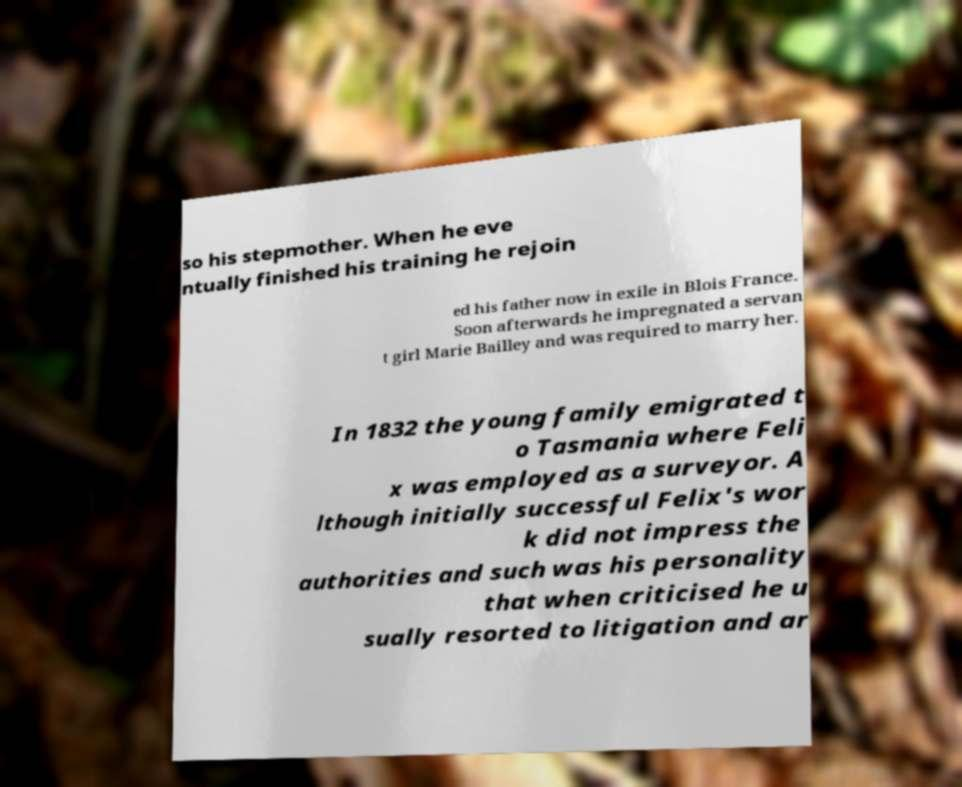Please read and relay the text visible in this image. What does it say? so his stepmother. When he eve ntually finished his training he rejoin ed his father now in exile in Blois France. Soon afterwards he impregnated a servan t girl Marie Bailley and was required to marry her. In 1832 the young family emigrated t o Tasmania where Feli x was employed as a surveyor. A lthough initially successful Felix's wor k did not impress the authorities and such was his personality that when criticised he u sually resorted to litigation and ar 